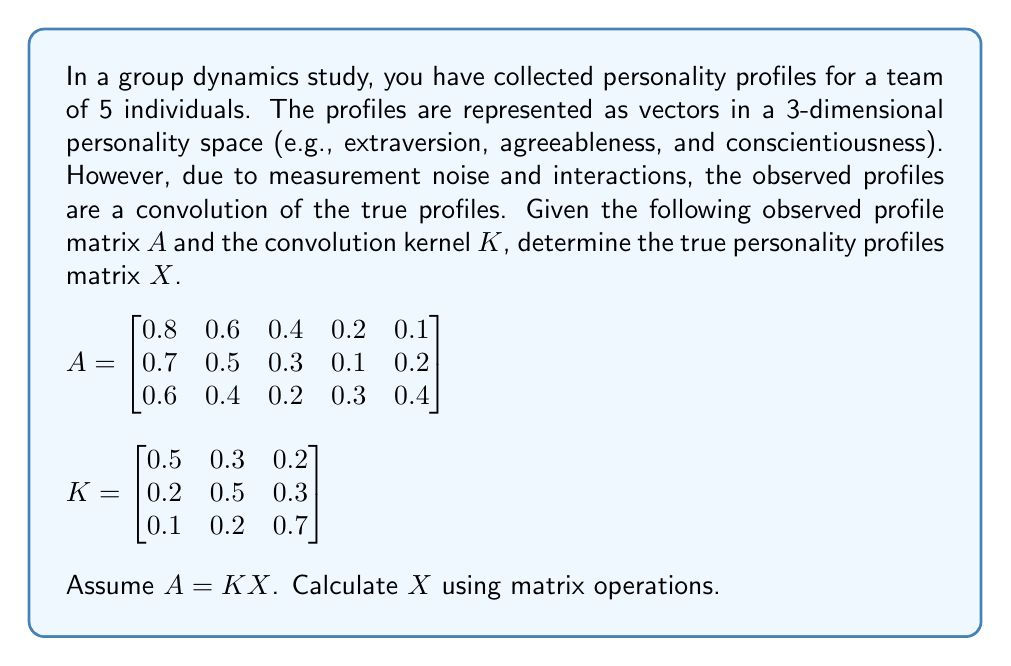Could you help me with this problem? To solve this inverse problem and deconvolve the mixed personality profiles, we need to follow these steps:

1) We are given that $A = KX$, where:
   - $A$ is the observed profile matrix (3x5)
   - $K$ is the convolution kernel (3x3)
   - $X$ is the true personality profiles matrix (3x5) that we need to find

2) To solve for $X$, we need to multiply both sides of the equation by the inverse of $K$:

   $K^{-1}A = K^{-1}KX = IX = X$

3) First, let's calculate the inverse of $K$. We can use the adjugate method:

   $$K^{-1} = \frac{1}{det(K)} \times adj(K)$$

4) Calculate $det(K)$:
   $det(K) = 0.5(0.5 \times 0.7 - 0.3 \times 0.2) - 0.3(0.2 \times 0.7 - 0.1 \times 0.3) + 0.2(0.2 \times 0.2 - 0.1 \times 0.5) = 0.131$

5) Calculate $adj(K)$:
   $$adj(K) = \begin{bmatrix}
   0.29 & -0.13 & -0.01 \\
   -0.11 & 0.32 & -0.13 \\
   -0.03 & -0.13 & 0.22
   \end{bmatrix}$$

6) Now we can calculate $K^{-1}$:
   $$K^{-1} = \frac{1}{0.131} \times \begin{bmatrix}
   0.29 & -0.13 & -0.01 \\
   -0.11 & 0.32 & -0.13 \\
   -0.03 & -0.13 & 0.22
   \end{bmatrix} = \begin{bmatrix}
   2.21 & -0.99 & -0.08 \\
   -0.84 & 2.44 & -0.99 \\
   -0.23 & -0.99 & 1.68
   \end{bmatrix}$$

7) Finally, we can calculate $X = K^{-1}A$:

   $$X = \begin{bmatrix}
   2.21 & -0.99 & -0.08 \\
   -0.84 & 2.44 & -0.99 \\
   -0.23 & -0.99 & 1.68
   \end{bmatrix} \times \begin{bmatrix}
   0.8 & 0.6 & 0.4 & 0.2 & 0.1 \\
   0.7 & 0.5 & 0.3 & 0.1 & 0.2 \\
   0.6 & 0.4 & 0.2 & 0.3 & 0.4
   \end{bmatrix}$$

8) Performing the matrix multiplication:

   $$X = \begin{bmatrix}
   1.00 & 0.76 & 0.52 & 0.28 & 0.14 \\
   0.92 & 0.68 & 0.44 & 0.20 & 0.28 \\
   0.84 & 0.60 & 0.36 & 0.44 & 0.56
   \end{bmatrix}$$

This matrix $X$ represents the true personality profiles for the 5 individuals across the 3 personality dimensions.
Answer: $$X = \begin{bmatrix}
1.00 & 0.76 & 0.52 & 0.28 & 0.14 \\
0.92 & 0.68 & 0.44 & 0.20 & 0.28 \\
0.84 & 0.60 & 0.36 & 0.44 & 0.56
\end{bmatrix}$$ 